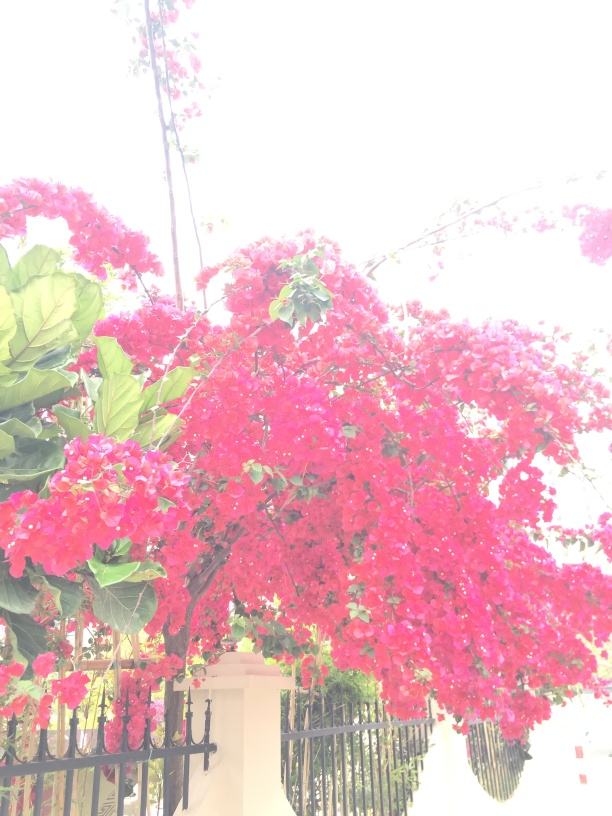Could you suggest some occasions or events where such flowers might be used as decorations? Certainly! Bougainvillea's vibrant and abundant blossoms make it an excellent choice for decorations during a variety of occasions such as weddings, garden parties, and cultural festivals. They can add a pop of color and a tropical feel to any event, being used in garlands, table centerpieces, or as a natural backdrop for photo opportunities. 